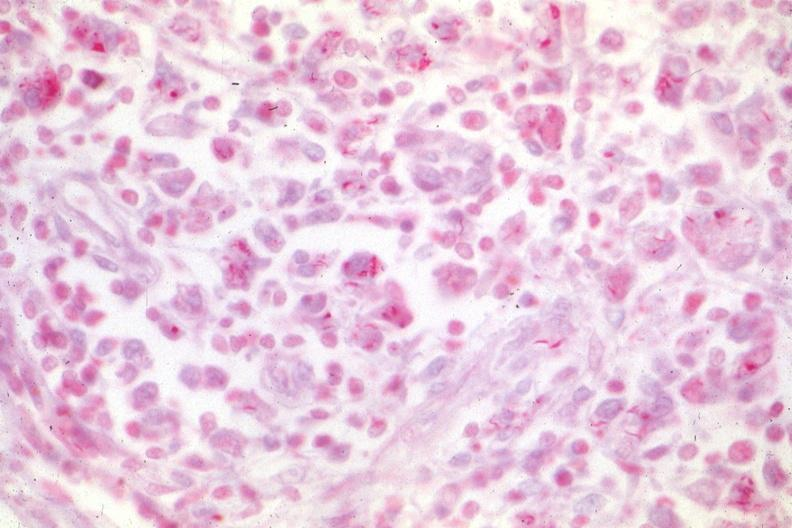what does this image show?
Answer the question using a single word or phrase. Typical case of hemophilia with aids 